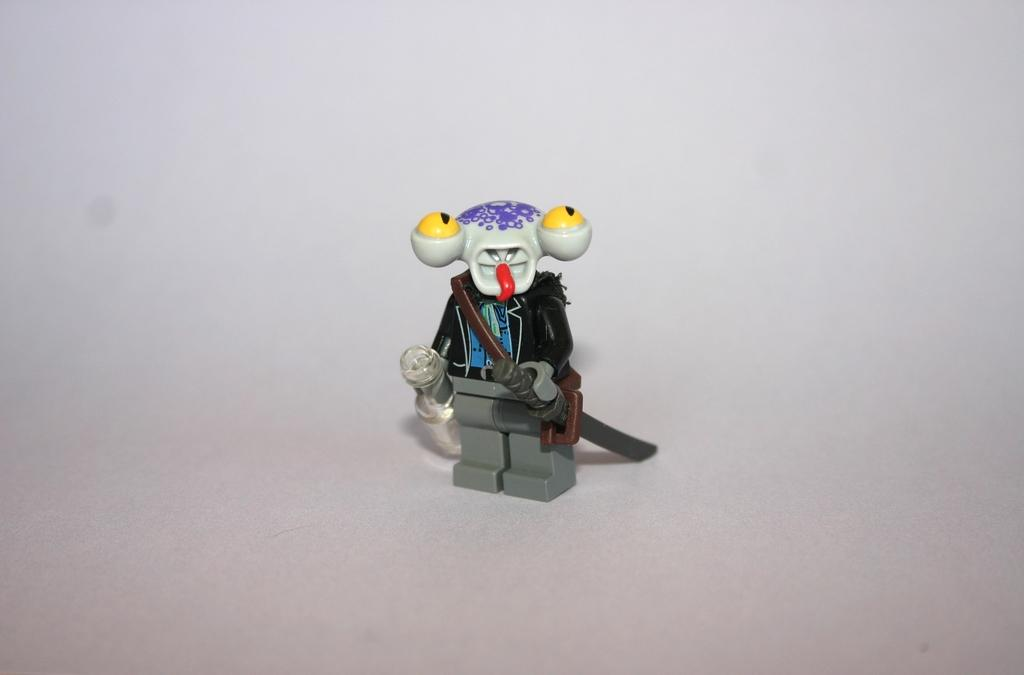What is the main subject of the image? The main subject of the image is a toy of a person. Can you describe the toy in more detail? Unfortunately, the facts provided do not give any additional details about the toy. Is the toy of a person the only object in the image? The facts provided do not mention any other objects in the image. How many chairs are placed around the toy in the image? There is no mention of chairs in the image, as the only fact provided is that there is a toy of a person in the image. 